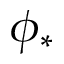Convert formula to latex. <formula><loc_0><loc_0><loc_500><loc_500>\phi _ { * }</formula> 